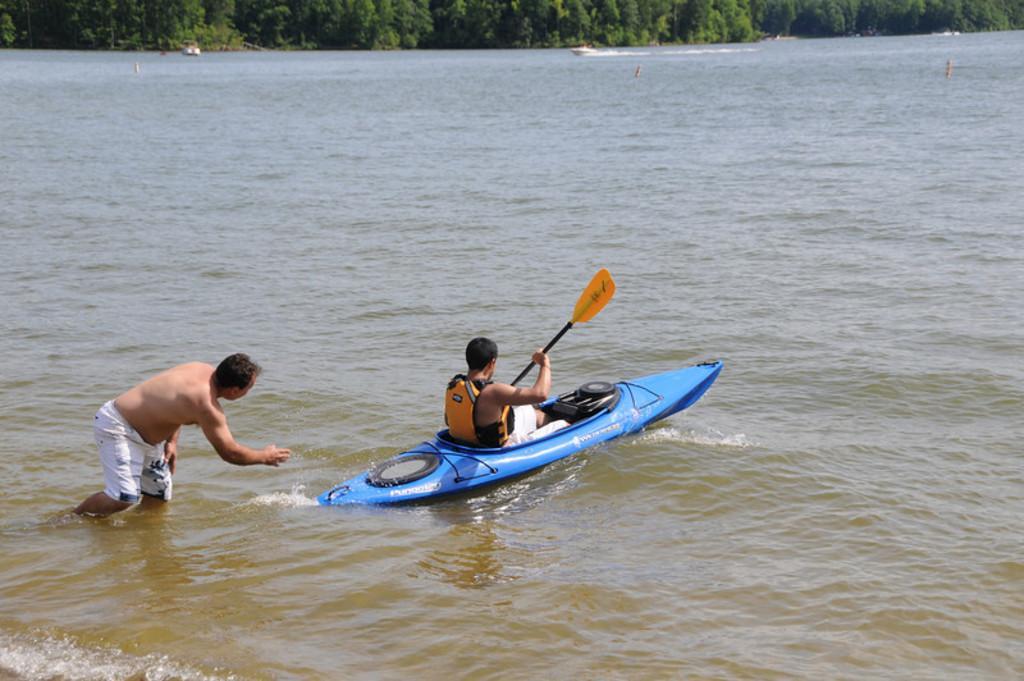Could you give a brief overview of what you see in this image? In this image there is a river, in that river a man is selling on a boat and other man is standing in the river, in the background there are trees. 